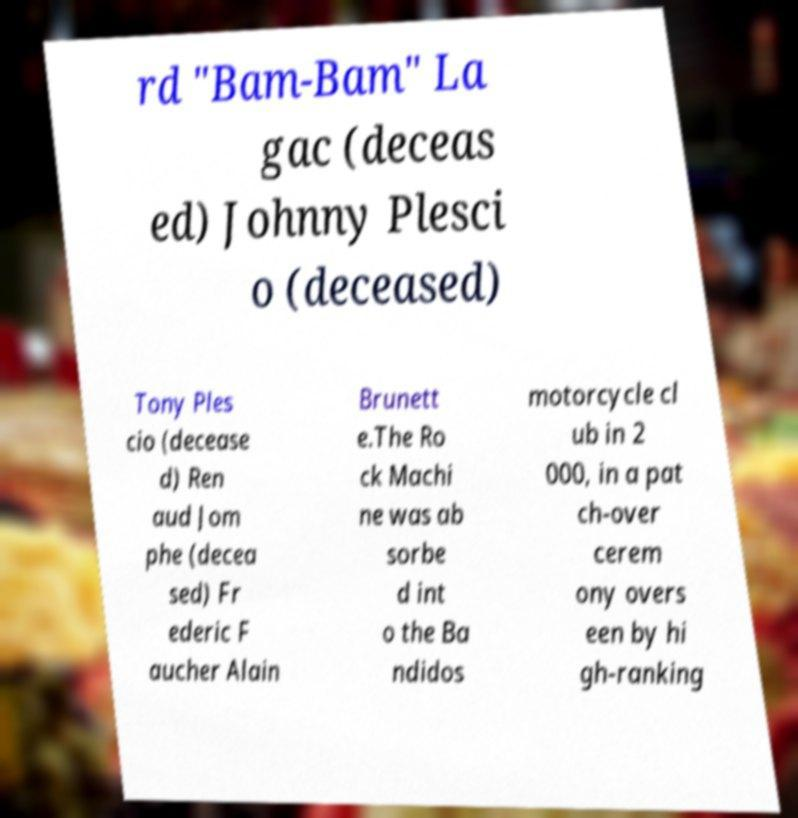What messages or text are displayed in this image? I need them in a readable, typed format. rd "Bam-Bam" La gac (deceas ed) Johnny Plesci o (deceased) Tony Ples cio (decease d) Ren aud Jom phe (decea sed) Fr ederic F aucher Alain Brunett e.The Ro ck Machi ne was ab sorbe d int o the Ba ndidos motorcycle cl ub in 2 000, in a pat ch-over cerem ony overs een by hi gh-ranking 